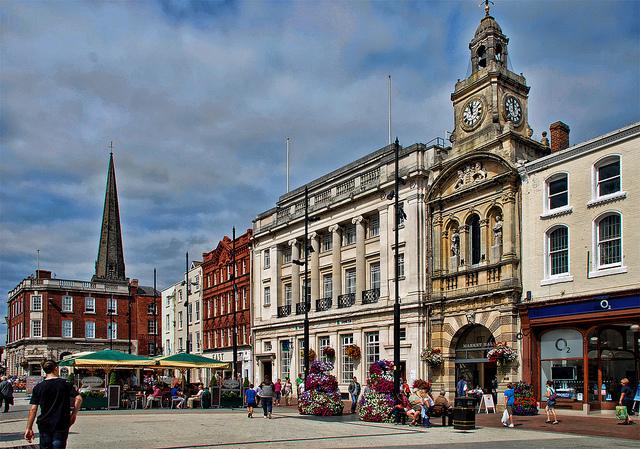What number of clocks are on this clock tower?
Keep it brief. 2. Sunny or hazy?
Give a very brief answer. Hazy. What color is the sky?
Write a very short answer. Blue. What is being sold in front of the clock tower?
Keep it brief. Flowers. 